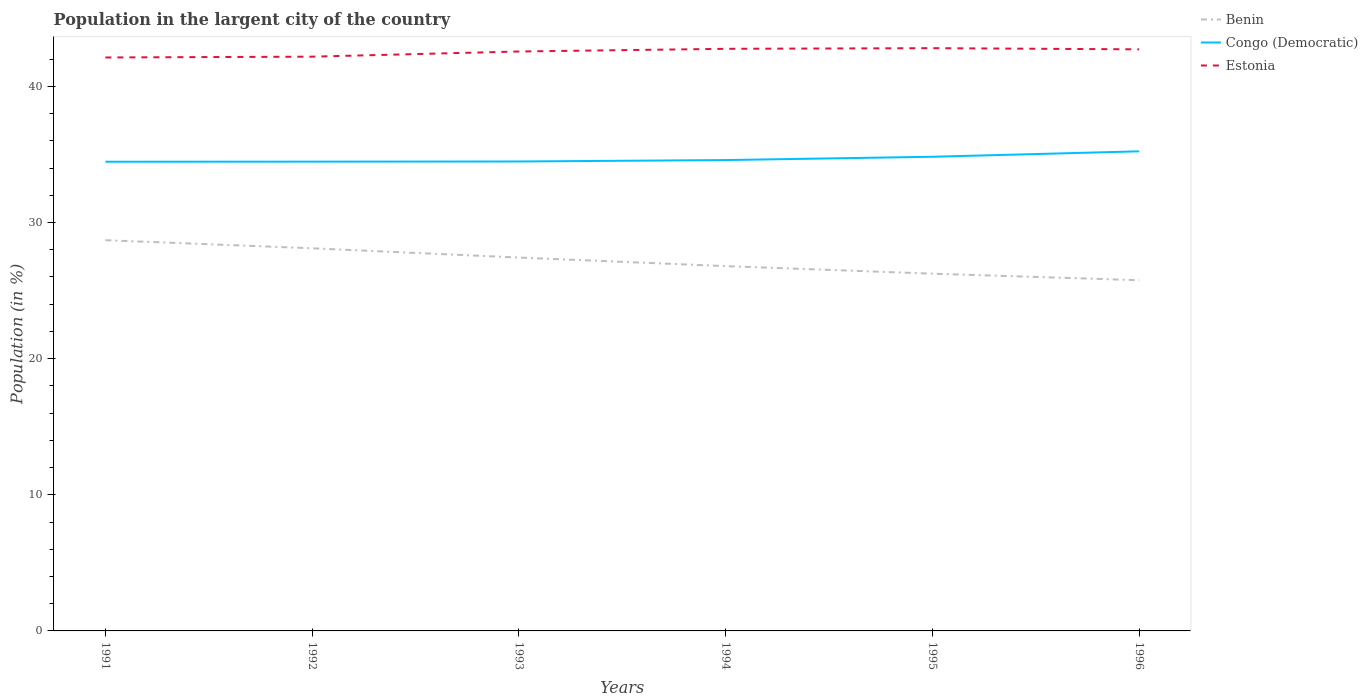Is the number of lines equal to the number of legend labels?
Give a very brief answer. Yes. Across all years, what is the maximum percentage of population in the largent city in Benin?
Provide a short and direct response. 25.76. In which year was the percentage of population in the largent city in Congo (Democratic) maximum?
Make the answer very short. 1991. What is the total percentage of population in the largent city in Congo (Democratic) in the graph?
Give a very brief answer. -0.75. What is the difference between the highest and the second highest percentage of population in the largent city in Estonia?
Provide a succinct answer. 0.68. How many lines are there?
Your response must be concise. 3. How many years are there in the graph?
Your response must be concise. 6. What is the difference between two consecutive major ticks on the Y-axis?
Your answer should be very brief. 10. Are the values on the major ticks of Y-axis written in scientific E-notation?
Make the answer very short. No. What is the title of the graph?
Provide a succinct answer. Population in the largent city of the country. What is the label or title of the X-axis?
Provide a short and direct response. Years. What is the Population (in %) in Benin in 1991?
Offer a very short reply. 28.7. What is the Population (in %) of Congo (Democratic) in 1991?
Offer a very short reply. 34.46. What is the Population (in %) of Estonia in 1991?
Make the answer very short. 42.12. What is the Population (in %) in Benin in 1992?
Your response must be concise. 28.11. What is the Population (in %) of Congo (Democratic) in 1992?
Offer a very short reply. 34.47. What is the Population (in %) of Estonia in 1992?
Make the answer very short. 42.18. What is the Population (in %) of Benin in 1993?
Offer a very short reply. 27.43. What is the Population (in %) of Congo (Democratic) in 1993?
Offer a very short reply. 34.48. What is the Population (in %) in Estonia in 1993?
Ensure brevity in your answer.  42.56. What is the Population (in %) of Benin in 1994?
Provide a succinct answer. 26.8. What is the Population (in %) of Congo (Democratic) in 1994?
Offer a very short reply. 34.59. What is the Population (in %) of Estonia in 1994?
Give a very brief answer. 42.76. What is the Population (in %) of Benin in 1995?
Give a very brief answer. 26.24. What is the Population (in %) of Congo (Democratic) in 1995?
Keep it short and to the point. 34.83. What is the Population (in %) of Estonia in 1995?
Provide a short and direct response. 42.81. What is the Population (in %) in Benin in 1996?
Ensure brevity in your answer.  25.76. What is the Population (in %) in Congo (Democratic) in 1996?
Your response must be concise. 35.23. What is the Population (in %) in Estonia in 1996?
Your answer should be very brief. 42.72. Across all years, what is the maximum Population (in %) of Benin?
Provide a succinct answer. 28.7. Across all years, what is the maximum Population (in %) in Congo (Democratic)?
Offer a very short reply. 35.23. Across all years, what is the maximum Population (in %) in Estonia?
Your answer should be very brief. 42.81. Across all years, what is the minimum Population (in %) of Benin?
Keep it short and to the point. 25.76. Across all years, what is the minimum Population (in %) in Congo (Democratic)?
Make the answer very short. 34.46. Across all years, what is the minimum Population (in %) of Estonia?
Your answer should be compact. 42.12. What is the total Population (in %) of Benin in the graph?
Give a very brief answer. 163.03. What is the total Population (in %) of Congo (Democratic) in the graph?
Make the answer very short. 208.06. What is the total Population (in %) in Estonia in the graph?
Offer a terse response. 255.15. What is the difference between the Population (in %) of Benin in 1991 and that in 1992?
Offer a terse response. 0.59. What is the difference between the Population (in %) in Congo (Democratic) in 1991 and that in 1992?
Ensure brevity in your answer.  -0.01. What is the difference between the Population (in %) of Estonia in 1991 and that in 1992?
Provide a short and direct response. -0.06. What is the difference between the Population (in %) of Benin in 1991 and that in 1993?
Your answer should be compact. 1.28. What is the difference between the Population (in %) of Congo (Democratic) in 1991 and that in 1993?
Make the answer very short. -0.02. What is the difference between the Population (in %) of Estonia in 1991 and that in 1993?
Give a very brief answer. -0.44. What is the difference between the Population (in %) in Benin in 1991 and that in 1994?
Offer a very short reply. 1.9. What is the difference between the Population (in %) in Congo (Democratic) in 1991 and that in 1994?
Provide a succinct answer. -0.12. What is the difference between the Population (in %) in Estonia in 1991 and that in 1994?
Your answer should be compact. -0.64. What is the difference between the Population (in %) of Benin in 1991 and that in 1995?
Keep it short and to the point. 2.46. What is the difference between the Population (in %) in Congo (Democratic) in 1991 and that in 1995?
Your answer should be compact. -0.37. What is the difference between the Population (in %) in Estonia in 1991 and that in 1995?
Offer a terse response. -0.68. What is the difference between the Population (in %) in Benin in 1991 and that in 1996?
Keep it short and to the point. 2.94. What is the difference between the Population (in %) of Congo (Democratic) in 1991 and that in 1996?
Offer a very short reply. -0.77. What is the difference between the Population (in %) of Estonia in 1991 and that in 1996?
Give a very brief answer. -0.6. What is the difference between the Population (in %) in Benin in 1992 and that in 1993?
Give a very brief answer. 0.68. What is the difference between the Population (in %) in Congo (Democratic) in 1992 and that in 1993?
Provide a succinct answer. -0.01. What is the difference between the Population (in %) of Estonia in 1992 and that in 1993?
Offer a terse response. -0.38. What is the difference between the Population (in %) in Benin in 1992 and that in 1994?
Your response must be concise. 1.31. What is the difference between the Population (in %) of Congo (Democratic) in 1992 and that in 1994?
Offer a very short reply. -0.12. What is the difference between the Population (in %) in Estonia in 1992 and that in 1994?
Give a very brief answer. -0.58. What is the difference between the Population (in %) of Benin in 1992 and that in 1995?
Offer a terse response. 1.86. What is the difference between the Population (in %) in Congo (Democratic) in 1992 and that in 1995?
Offer a very short reply. -0.36. What is the difference between the Population (in %) in Estonia in 1992 and that in 1995?
Keep it short and to the point. -0.62. What is the difference between the Population (in %) of Benin in 1992 and that in 1996?
Make the answer very short. 2.35. What is the difference between the Population (in %) in Congo (Democratic) in 1992 and that in 1996?
Keep it short and to the point. -0.76. What is the difference between the Population (in %) in Estonia in 1992 and that in 1996?
Your answer should be very brief. -0.54. What is the difference between the Population (in %) of Benin in 1993 and that in 1994?
Provide a succinct answer. 0.63. What is the difference between the Population (in %) in Congo (Democratic) in 1993 and that in 1994?
Provide a succinct answer. -0.1. What is the difference between the Population (in %) of Estonia in 1993 and that in 1994?
Your answer should be compact. -0.2. What is the difference between the Population (in %) in Benin in 1993 and that in 1995?
Provide a short and direct response. 1.18. What is the difference between the Population (in %) in Congo (Democratic) in 1993 and that in 1995?
Your answer should be very brief. -0.35. What is the difference between the Population (in %) in Estonia in 1993 and that in 1995?
Make the answer very short. -0.24. What is the difference between the Population (in %) in Benin in 1993 and that in 1996?
Provide a succinct answer. 1.66. What is the difference between the Population (in %) in Congo (Democratic) in 1993 and that in 1996?
Offer a very short reply. -0.75. What is the difference between the Population (in %) in Estonia in 1993 and that in 1996?
Ensure brevity in your answer.  -0.16. What is the difference between the Population (in %) in Benin in 1994 and that in 1995?
Keep it short and to the point. 0.56. What is the difference between the Population (in %) in Congo (Democratic) in 1994 and that in 1995?
Provide a succinct answer. -0.24. What is the difference between the Population (in %) of Estonia in 1994 and that in 1995?
Provide a short and direct response. -0.05. What is the difference between the Population (in %) of Benin in 1994 and that in 1996?
Keep it short and to the point. 1.04. What is the difference between the Population (in %) of Congo (Democratic) in 1994 and that in 1996?
Your answer should be compact. -0.64. What is the difference between the Population (in %) in Estonia in 1994 and that in 1996?
Ensure brevity in your answer.  0.04. What is the difference between the Population (in %) of Benin in 1995 and that in 1996?
Ensure brevity in your answer.  0.48. What is the difference between the Population (in %) of Estonia in 1995 and that in 1996?
Give a very brief answer. 0.09. What is the difference between the Population (in %) of Benin in 1991 and the Population (in %) of Congo (Democratic) in 1992?
Your answer should be compact. -5.77. What is the difference between the Population (in %) of Benin in 1991 and the Population (in %) of Estonia in 1992?
Your response must be concise. -13.48. What is the difference between the Population (in %) in Congo (Democratic) in 1991 and the Population (in %) in Estonia in 1992?
Provide a short and direct response. -7.72. What is the difference between the Population (in %) of Benin in 1991 and the Population (in %) of Congo (Democratic) in 1993?
Your answer should be very brief. -5.78. What is the difference between the Population (in %) of Benin in 1991 and the Population (in %) of Estonia in 1993?
Your answer should be very brief. -13.86. What is the difference between the Population (in %) of Congo (Democratic) in 1991 and the Population (in %) of Estonia in 1993?
Give a very brief answer. -8.1. What is the difference between the Population (in %) in Benin in 1991 and the Population (in %) in Congo (Democratic) in 1994?
Ensure brevity in your answer.  -5.89. What is the difference between the Population (in %) of Benin in 1991 and the Population (in %) of Estonia in 1994?
Make the answer very short. -14.06. What is the difference between the Population (in %) in Congo (Democratic) in 1991 and the Population (in %) in Estonia in 1994?
Ensure brevity in your answer.  -8.3. What is the difference between the Population (in %) in Benin in 1991 and the Population (in %) in Congo (Democratic) in 1995?
Make the answer very short. -6.13. What is the difference between the Population (in %) in Benin in 1991 and the Population (in %) in Estonia in 1995?
Your answer should be compact. -14.1. What is the difference between the Population (in %) in Congo (Democratic) in 1991 and the Population (in %) in Estonia in 1995?
Your answer should be compact. -8.34. What is the difference between the Population (in %) of Benin in 1991 and the Population (in %) of Congo (Democratic) in 1996?
Keep it short and to the point. -6.53. What is the difference between the Population (in %) of Benin in 1991 and the Population (in %) of Estonia in 1996?
Provide a succinct answer. -14.02. What is the difference between the Population (in %) of Congo (Democratic) in 1991 and the Population (in %) of Estonia in 1996?
Offer a very short reply. -8.26. What is the difference between the Population (in %) in Benin in 1992 and the Population (in %) in Congo (Democratic) in 1993?
Give a very brief answer. -6.38. What is the difference between the Population (in %) of Benin in 1992 and the Population (in %) of Estonia in 1993?
Keep it short and to the point. -14.46. What is the difference between the Population (in %) of Congo (Democratic) in 1992 and the Population (in %) of Estonia in 1993?
Make the answer very short. -8.09. What is the difference between the Population (in %) of Benin in 1992 and the Population (in %) of Congo (Democratic) in 1994?
Offer a very short reply. -6.48. What is the difference between the Population (in %) in Benin in 1992 and the Population (in %) in Estonia in 1994?
Your response must be concise. -14.65. What is the difference between the Population (in %) in Congo (Democratic) in 1992 and the Population (in %) in Estonia in 1994?
Your response must be concise. -8.29. What is the difference between the Population (in %) of Benin in 1992 and the Population (in %) of Congo (Democratic) in 1995?
Keep it short and to the point. -6.72. What is the difference between the Population (in %) in Benin in 1992 and the Population (in %) in Estonia in 1995?
Ensure brevity in your answer.  -14.7. What is the difference between the Population (in %) of Congo (Democratic) in 1992 and the Population (in %) of Estonia in 1995?
Your answer should be very brief. -8.33. What is the difference between the Population (in %) of Benin in 1992 and the Population (in %) of Congo (Democratic) in 1996?
Ensure brevity in your answer.  -7.12. What is the difference between the Population (in %) in Benin in 1992 and the Population (in %) in Estonia in 1996?
Keep it short and to the point. -14.61. What is the difference between the Population (in %) in Congo (Democratic) in 1992 and the Population (in %) in Estonia in 1996?
Give a very brief answer. -8.25. What is the difference between the Population (in %) in Benin in 1993 and the Population (in %) in Congo (Democratic) in 1994?
Offer a very short reply. -7.16. What is the difference between the Population (in %) of Benin in 1993 and the Population (in %) of Estonia in 1994?
Keep it short and to the point. -15.33. What is the difference between the Population (in %) of Congo (Democratic) in 1993 and the Population (in %) of Estonia in 1994?
Your response must be concise. -8.28. What is the difference between the Population (in %) in Benin in 1993 and the Population (in %) in Congo (Democratic) in 1995?
Make the answer very short. -7.4. What is the difference between the Population (in %) of Benin in 1993 and the Population (in %) of Estonia in 1995?
Ensure brevity in your answer.  -15.38. What is the difference between the Population (in %) of Congo (Democratic) in 1993 and the Population (in %) of Estonia in 1995?
Offer a very short reply. -8.32. What is the difference between the Population (in %) in Benin in 1993 and the Population (in %) in Congo (Democratic) in 1996?
Offer a terse response. -7.8. What is the difference between the Population (in %) in Benin in 1993 and the Population (in %) in Estonia in 1996?
Provide a short and direct response. -15.29. What is the difference between the Population (in %) of Congo (Democratic) in 1993 and the Population (in %) of Estonia in 1996?
Keep it short and to the point. -8.24. What is the difference between the Population (in %) in Benin in 1994 and the Population (in %) in Congo (Democratic) in 1995?
Offer a very short reply. -8.03. What is the difference between the Population (in %) in Benin in 1994 and the Population (in %) in Estonia in 1995?
Your answer should be compact. -16.01. What is the difference between the Population (in %) of Congo (Democratic) in 1994 and the Population (in %) of Estonia in 1995?
Provide a succinct answer. -8.22. What is the difference between the Population (in %) in Benin in 1994 and the Population (in %) in Congo (Democratic) in 1996?
Offer a terse response. -8.43. What is the difference between the Population (in %) of Benin in 1994 and the Population (in %) of Estonia in 1996?
Offer a terse response. -15.92. What is the difference between the Population (in %) in Congo (Democratic) in 1994 and the Population (in %) in Estonia in 1996?
Provide a short and direct response. -8.13. What is the difference between the Population (in %) of Benin in 1995 and the Population (in %) of Congo (Democratic) in 1996?
Your response must be concise. -8.99. What is the difference between the Population (in %) in Benin in 1995 and the Population (in %) in Estonia in 1996?
Your answer should be very brief. -16.48. What is the difference between the Population (in %) of Congo (Democratic) in 1995 and the Population (in %) of Estonia in 1996?
Provide a succinct answer. -7.89. What is the average Population (in %) of Benin per year?
Give a very brief answer. 27.17. What is the average Population (in %) in Congo (Democratic) per year?
Ensure brevity in your answer.  34.68. What is the average Population (in %) of Estonia per year?
Offer a very short reply. 42.53. In the year 1991, what is the difference between the Population (in %) in Benin and Population (in %) in Congo (Democratic)?
Your answer should be very brief. -5.76. In the year 1991, what is the difference between the Population (in %) in Benin and Population (in %) in Estonia?
Your answer should be compact. -13.42. In the year 1991, what is the difference between the Population (in %) of Congo (Democratic) and Population (in %) of Estonia?
Make the answer very short. -7.66. In the year 1992, what is the difference between the Population (in %) in Benin and Population (in %) in Congo (Democratic)?
Ensure brevity in your answer.  -6.36. In the year 1992, what is the difference between the Population (in %) in Benin and Population (in %) in Estonia?
Your response must be concise. -14.08. In the year 1992, what is the difference between the Population (in %) of Congo (Democratic) and Population (in %) of Estonia?
Ensure brevity in your answer.  -7.71. In the year 1993, what is the difference between the Population (in %) of Benin and Population (in %) of Congo (Democratic)?
Ensure brevity in your answer.  -7.06. In the year 1993, what is the difference between the Population (in %) in Benin and Population (in %) in Estonia?
Your answer should be very brief. -15.14. In the year 1993, what is the difference between the Population (in %) of Congo (Democratic) and Population (in %) of Estonia?
Make the answer very short. -8.08. In the year 1994, what is the difference between the Population (in %) in Benin and Population (in %) in Congo (Democratic)?
Provide a short and direct response. -7.79. In the year 1994, what is the difference between the Population (in %) of Benin and Population (in %) of Estonia?
Your answer should be very brief. -15.96. In the year 1994, what is the difference between the Population (in %) of Congo (Democratic) and Population (in %) of Estonia?
Provide a succinct answer. -8.17. In the year 1995, what is the difference between the Population (in %) in Benin and Population (in %) in Congo (Democratic)?
Your answer should be compact. -8.59. In the year 1995, what is the difference between the Population (in %) of Benin and Population (in %) of Estonia?
Your answer should be very brief. -16.56. In the year 1995, what is the difference between the Population (in %) of Congo (Democratic) and Population (in %) of Estonia?
Make the answer very short. -7.98. In the year 1996, what is the difference between the Population (in %) of Benin and Population (in %) of Congo (Democratic)?
Keep it short and to the point. -9.47. In the year 1996, what is the difference between the Population (in %) of Benin and Population (in %) of Estonia?
Your answer should be very brief. -16.96. In the year 1996, what is the difference between the Population (in %) in Congo (Democratic) and Population (in %) in Estonia?
Provide a succinct answer. -7.49. What is the ratio of the Population (in %) in Benin in 1991 to that in 1992?
Your answer should be compact. 1.02. What is the ratio of the Population (in %) in Benin in 1991 to that in 1993?
Provide a succinct answer. 1.05. What is the ratio of the Population (in %) of Congo (Democratic) in 1991 to that in 1993?
Make the answer very short. 1. What is the ratio of the Population (in %) in Estonia in 1991 to that in 1993?
Your response must be concise. 0.99. What is the ratio of the Population (in %) in Benin in 1991 to that in 1994?
Provide a succinct answer. 1.07. What is the ratio of the Population (in %) in Congo (Democratic) in 1991 to that in 1994?
Provide a succinct answer. 1. What is the ratio of the Population (in %) of Estonia in 1991 to that in 1994?
Your response must be concise. 0.99. What is the ratio of the Population (in %) in Benin in 1991 to that in 1995?
Give a very brief answer. 1.09. What is the ratio of the Population (in %) of Congo (Democratic) in 1991 to that in 1995?
Offer a very short reply. 0.99. What is the ratio of the Population (in %) of Benin in 1991 to that in 1996?
Give a very brief answer. 1.11. What is the ratio of the Population (in %) in Congo (Democratic) in 1991 to that in 1996?
Your answer should be compact. 0.98. What is the ratio of the Population (in %) of Estonia in 1991 to that in 1996?
Offer a terse response. 0.99. What is the ratio of the Population (in %) in Benin in 1992 to that in 1993?
Your answer should be very brief. 1.02. What is the ratio of the Population (in %) of Estonia in 1992 to that in 1993?
Provide a succinct answer. 0.99. What is the ratio of the Population (in %) in Benin in 1992 to that in 1994?
Offer a terse response. 1.05. What is the ratio of the Population (in %) in Congo (Democratic) in 1992 to that in 1994?
Provide a succinct answer. 1. What is the ratio of the Population (in %) in Estonia in 1992 to that in 1994?
Your answer should be compact. 0.99. What is the ratio of the Population (in %) in Benin in 1992 to that in 1995?
Make the answer very short. 1.07. What is the ratio of the Population (in %) in Estonia in 1992 to that in 1995?
Your answer should be compact. 0.99. What is the ratio of the Population (in %) of Benin in 1992 to that in 1996?
Your response must be concise. 1.09. What is the ratio of the Population (in %) of Congo (Democratic) in 1992 to that in 1996?
Provide a succinct answer. 0.98. What is the ratio of the Population (in %) of Estonia in 1992 to that in 1996?
Ensure brevity in your answer.  0.99. What is the ratio of the Population (in %) of Benin in 1993 to that in 1994?
Your answer should be very brief. 1.02. What is the ratio of the Population (in %) of Congo (Democratic) in 1993 to that in 1994?
Keep it short and to the point. 1. What is the ratio of the Population (in %) in Benin in 1993 to that in 1995?
Your response must be concise. 1.05. What is the ratio of the Population (in %) of Benin in 1993 to that in 1996?
Provide a succinct answer. 1.06. What is the ratio of the Population (in %) in Congo (Democratic) in 1993 to that in 1996?
Your response must be concise. 0.98. What is the ratio of the Population (in %) in Estonia in 1993 to that in 1996?
Your response must be concise. 1. What is the ratio of the Population (in %) of Benin in 1994 to that in 1995?
Your answer should be very brief. 1.02. What is the ratio of the Population (in %) in Congo (Democratic) in 1994 to that in 1995?
Your answer should be compact. 0.99. What is the ratio of the Population (in %) of Benin in 1994 to that in 1996?
Keep it short and to the point. 1.04. What is the ratio of the Population (in %) of Congo (Democratic) in 1994 to that in 1996?
Provide a short and direct response. 0.98. What is the ratio of the Population (in %) of Benin in 1995 to that in 1996?
Give a very brief answer. 1.02. What is the ratio of the Population (in %) of Estonia in 1995 to that in 1996?
Your answer should be very brief. 1. What is the difference between the highest and the second highest Population (in %) in Benin?
Ensure brevity in your answer.  0.59. What is the difference between the highest and the second highest Population (in %) of Congo (Democratic)?
Your answer should be compact. 0.4. What is the difference between the highest and the second highest Population (in %) in Estonia?
Keep it short and to the point. 0.05. What is the difference between the highest and the lowest Population (in %) of Benin?
Your answer should be very brief. 2.94. What is the difference between the highest and the lowest Population (in %) in Congo (Democratic)?
Your answer should be very brief. 0.77. What is the difference between the highest and the lowest Population (in %) of Estonia?
Ensure brevity in your answer.  0.68. 